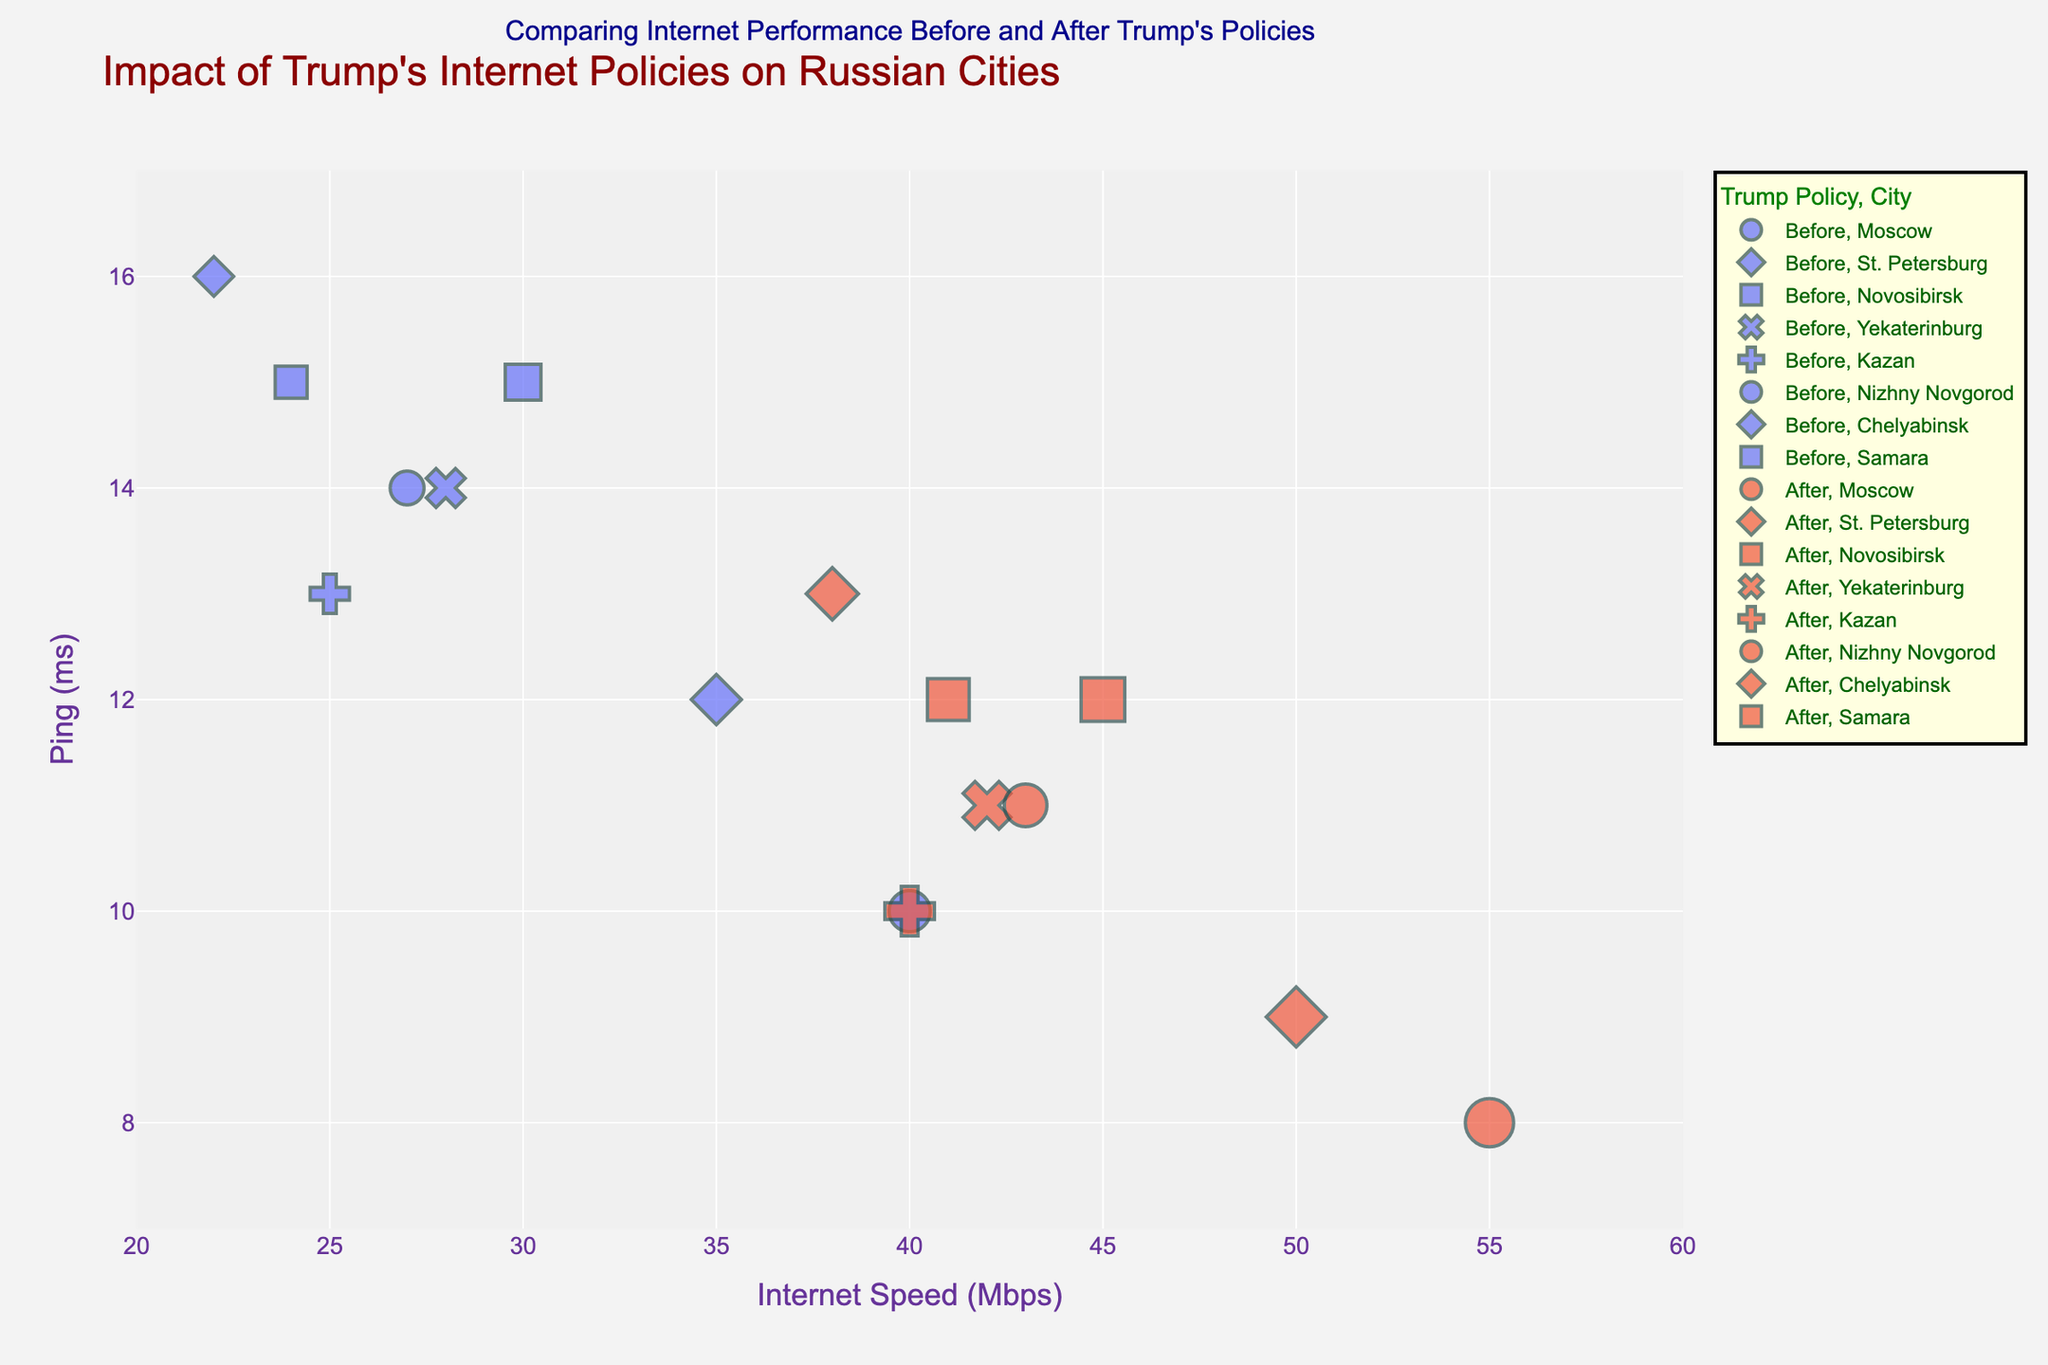What's the title of the figure? The title is the text prominently displayed at the top of the figure. In this case, it is "Impact of Trump's Internet Policies on Russian Cities."
Answer: Impact of Trump's Internet Policies on Russian Cities How many cities are analyzed in the figure? The figure plots data for different cities, each represented by unique symbols. There are 8 distinct cities shown in the hover data and legends.
Answer: 8 What is the general trend in Internet speed from 2016 to 2018? By observing the data points, we notice that the Internet speed has increased in all cities from 2016 to 2018.
Answer: Increased Which city had the highest Internet speed in 2018? Looking at the x-axis for the data points labeled with 2018, we can see that Moscow had the highest Internet speed.
Answer: Moscow What is the difference in Ping between Moscow in 2016 and 2018? In 2016, Moscow had a Ping of 10 ms, and in 2018, it had a Ping of 8 ms. The difference is calculated as 10 - 8 ms.
Answer: 2 ms Which city shows the least improvement in Internet speed from 2016 to 2018? Compare the horizontal distance between data points from 2016 to 2018 for each city. Chelyabinsk shows the smallest increase from 22 to 38 Mbps, giving an improvement of 16 Mbps.
Answer: Chelyabinsk Did any city show an increase in Ping from 2016 to 2018? By checking the data points for each city, one can see the Ping values. No city shows increased Ping; all have reduced.
Answer: No Which city had the highest Ping in 2016? Look at the y-axis for data points labeled with 2016; Chelyabinsk has the highest Ping at 16 ms.
Answer: Chelyabinsk How do the Ping values generally change from 2016 to 2018 for all cities? By observing the position of the data points on the y-axis, we see that the Ping values decrease from 2016 to 2018.
Answer: Decreased What is the average Internet speed of all cities in 2018? The Internet speeds for 2018 are: 55, 50, 45, 42, 40, 43, 38, 41 Mbps. The sum is 354 Mbps, and there are 8 cities. Therefore, the average is 354/8 = 44.25 Mbps.
Answer: 44.25 Mbps 